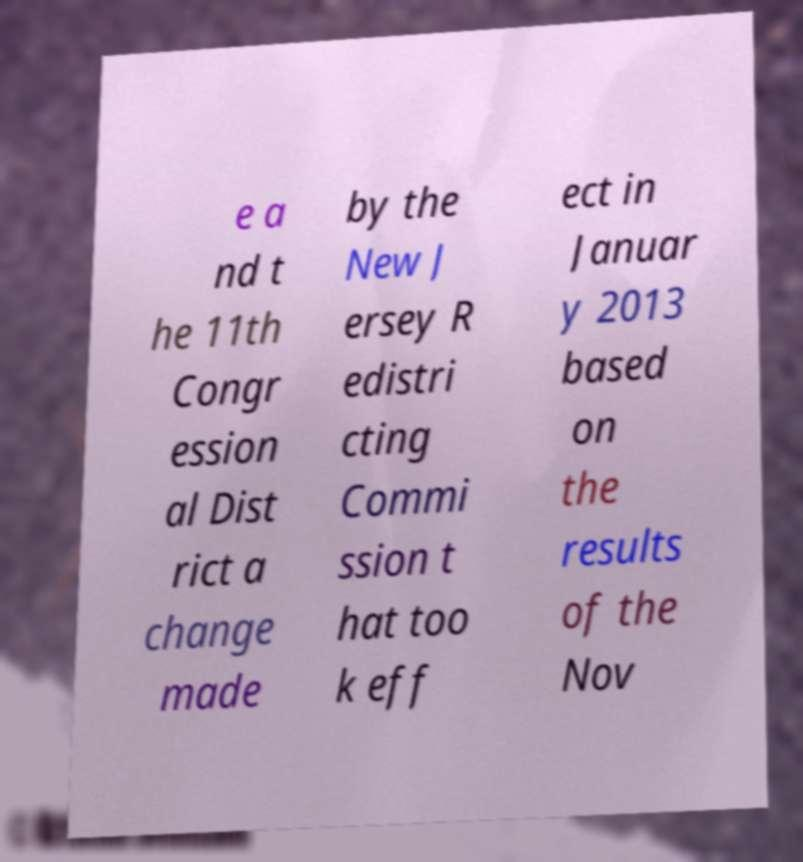Could you assist in decoding the text presented in this image and type it out clearly? e a nd t he 11th Congr ession al Dist rict a change made by the New J ersey R edistri cting Commi ssion t hat too k eff ect in Januar y 2013 based on the results of the Nov 